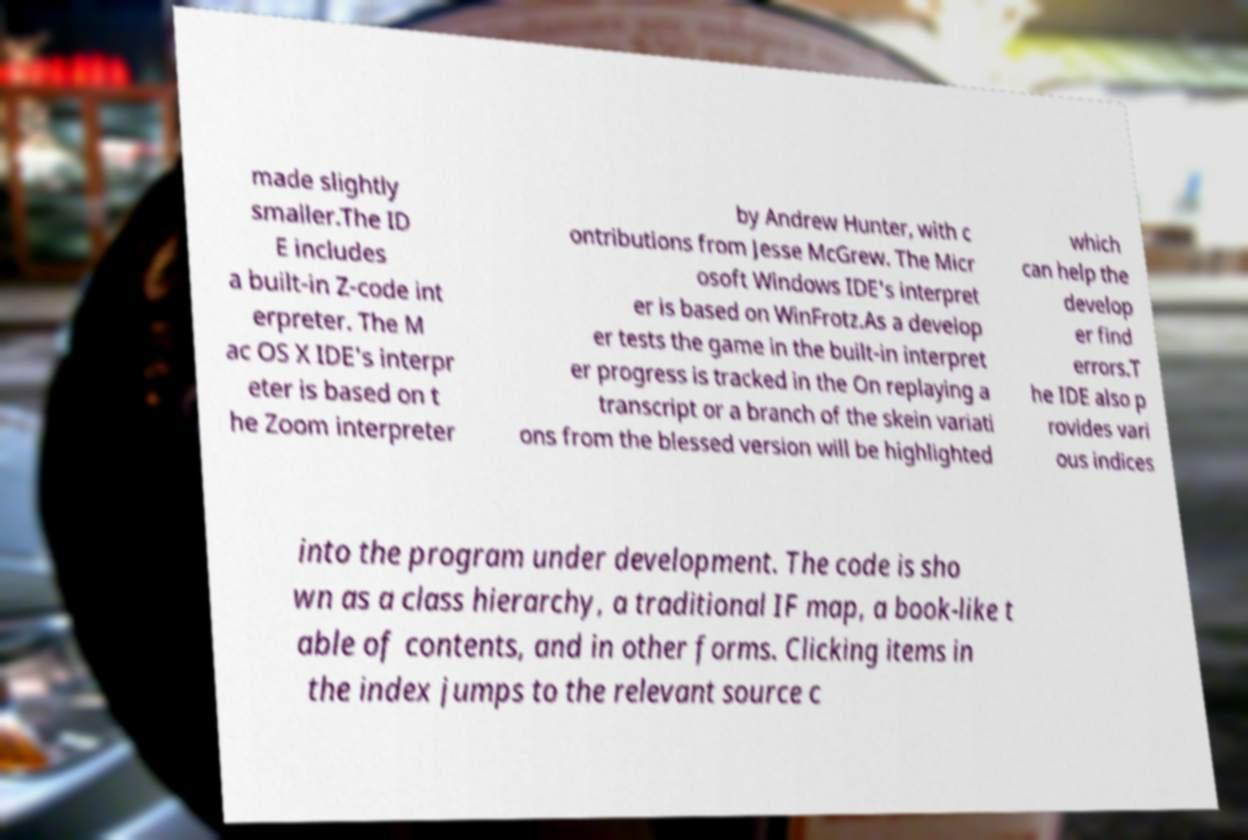Please identify and transcribe the text found in this image. made slightly smaller.The ID E includes a built-in Z-code int erpreter. The M ac OS X IDE's interpr eter is based on t he Zoom interpreter by Andrew Hunter, with c ontributions from Jesse McGrew. The Micr osoft Windows IDE's interpret er is based on WinFrotz.As a develop er tests the game in the built-in interpret er progress is tracked in the On replaying a transcript or a branch of the skein variati ons from the blessed version will be highlighted which can help the develop er find errors.T he IDE also p rovides vari ous indices into the program under development. The code is sho wn as a class hierarchy, a traditional IF map, a book-like t able of contents, and in other forms. Clicking items in the index jumps to the relevant source c 